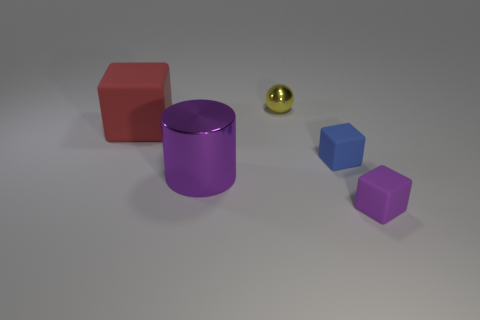Is the number of purple cylinders that are left of the big cylinder less than the number of objects that are on the left side of the yellow shiny thing?
Keep it short and to the point. Yes. Are there any other things that have the same shape as the small yellow thing?
Provide a short and direct response. No. The other big thing that is the same shape as the blue thing is what color?
Keep it short and to the point. Red. There is a big purple metallic thing; is its shape the same as the object that is behind the large red thing?
Offer a very short reply. No. What number of things are purple metal things in front of the tiny yellow ball or cubes that are behind the shiny cylinder?
Your response must be concise. 3. What is the large cylinder made of?
Give a very brief answer. Metal. What number of other things are there of the same size as the purple metal cylinder?
Provide a succinct answer. 1. What is the size of the thing that is behind the large red matte thing?
Provide a succinct answer. Small. There is a tiny cube that is to the left of the purple object to the right of the big object that is on the right side of the red matte thing; what is it made of?
Ensure brevity in your answer.  Rubber. Is the shape of the tiny blue matte object the same as the red thing?
Your response must be concise. Yes. 